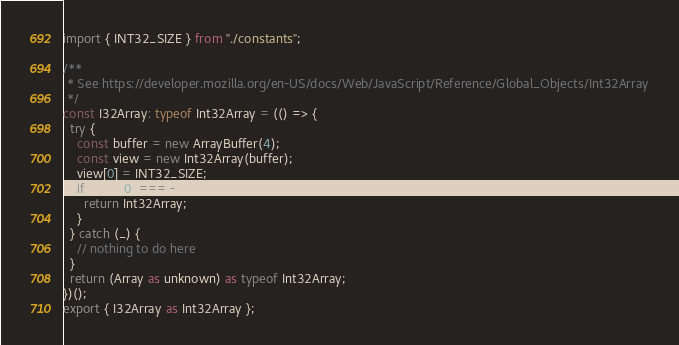<code> <loc_0><loc_0><loc_500><loc_500><_TypeScript_>import { INT32_SIZE } from "./constants";

/**
 * See https://developer.mozilla.org/en-US/docs/Web/JavaScript/Reference/Global_Objects/Int32Array
 */
const I32Array: typeof Int32Array = (() => {
  try {
    const buffer = new ArrayBuffer(4);
    const view = new Int32Array(buffer);
    view[0] = INT32_SIZE;
    if (view[0] === -INT32_SIZE) {
      return Int32Array;
    }
  } catch (_) {
    // nothing to do here
  }
  return (Array as unknown) as typeof Int32Array;
})();
export { I32Array as Int32Array };
</code> 